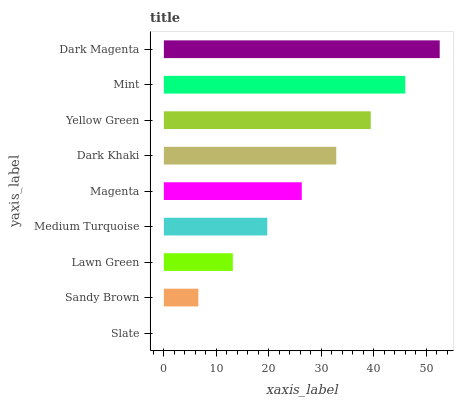Is Slate the minimum?
Answer yes or no. Yes. Is Dark Magenta the maximum?
Answer yes or no. Yes. Is Sandy Brown the minimum?
Answer yes or no. No. Is Sandy Brown the maximum?
Answer yes or no. No. Is Sandy Brown greater than Slate?
Answer yes or no. Yes. Is Slate less than Sandy Brown?
Answer yes or no. Yes. Is Slate greater than Sandy Brown?
Answer yes or no. No. Is Sandy Brown less than Slate?
Answer yes or no. No. Is Magenta the high median?
Answer yes or no. Yes. Is Magenta the low median?
Answer yes or no. Yes. Is Dark Khaki the high median?
Answer yes or no. No. Is Lawn Green the low median?
Answer yes or no. No. 